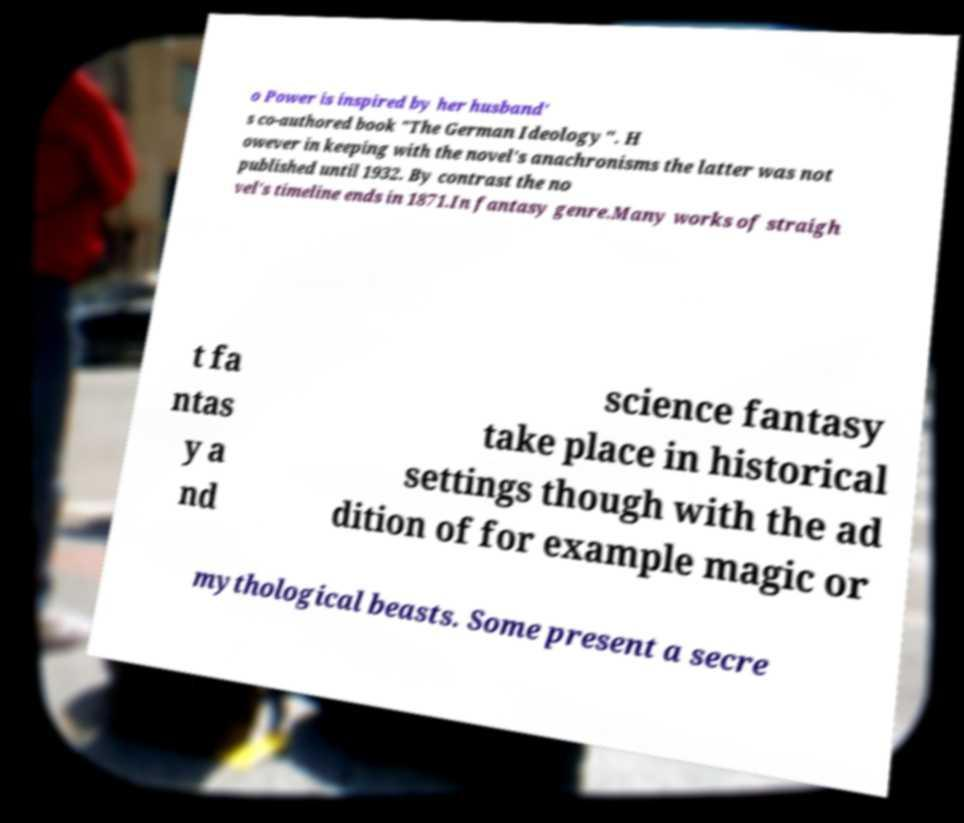Please identify and transcribe the text found in this image. o Power is inspired by her husband' s co-authored book "The German Ideology". H owever in keeping with the novel's anachronisms the latter was not published until 1932. By contrast the no vel's timeline ends in 1871.In fantasy genre.Many works of straigh t fa ntas y a nd science fantasy take place in historical settings though with the ad dition of for example magic or mythological beasts. Some present a secre 